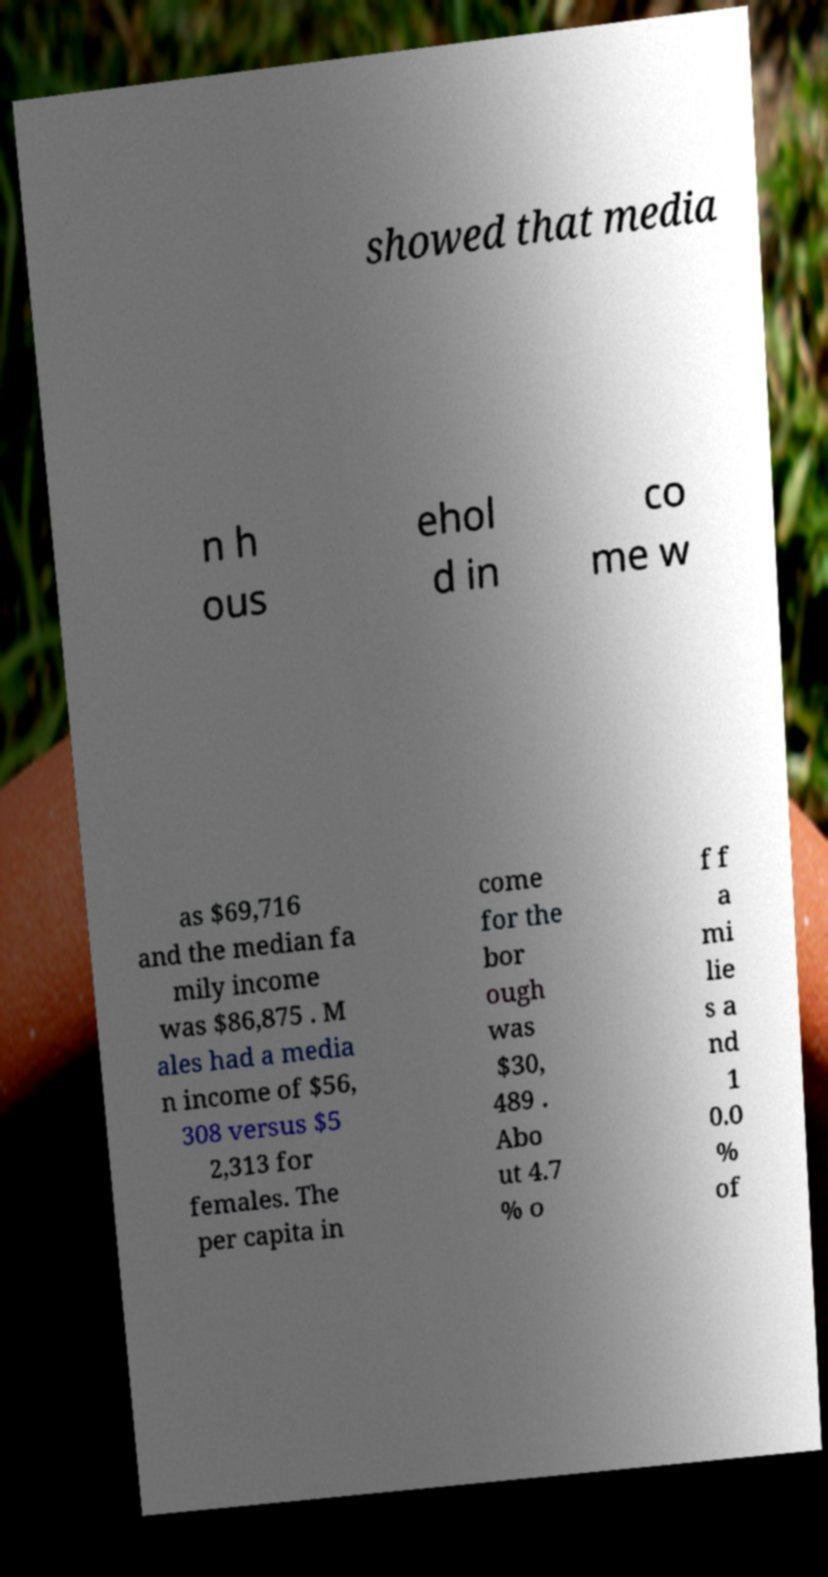I need the written content from this picture converted into text. Can you do that? showed that media n h ous ehol d in co me w as $69,716 and the median fa mily income was $86,875 . M ales had a media n income of $56, 308 versus $5 2,313 for females. The per capita in come for the bor ough was $30, 489 . Abo ut 4.7 % o f f a mi lie s a nd 1 0.0 % of 